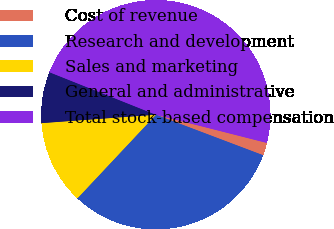Convert chart. <chart><loc_0><loc_0><loc_500><loc_500><pie_chart><fcel>Cost of revenue<fcel>Research and development<fcel>Sales and marketing<fcel>General and administrative<fcel>Total stock-based compensation<nl><fcel>1.79%<fcel>31.24%<fcel>11.83%<fcel>7.22%<fcel>47.91%<nl></chart> 